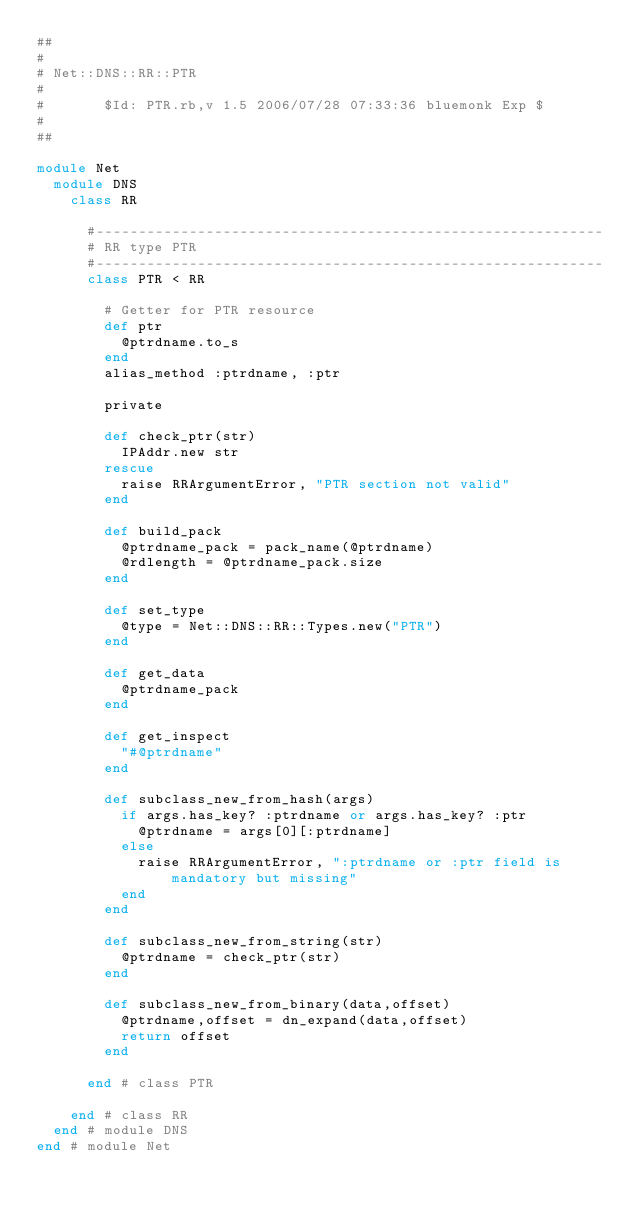<code> <loc_0><loc_0><loc_500><loc_500><_Ruby_>##
#
# Net::DNS::RR::PTR
#
#       $Id: PTR.rb,v 1.5 2006/07/28 07:33:36 bluemonk Exp $    
#
##

module Net
  module DNS
    class RR
      
      #------------------------------------------------------------
      # RR type PTR
      #------------------------------------------------------------
      class PTR < RR

        # Getter for PTR resource
        def ptr
          @ptrdname.to_s
        end
        alias_method :ptrdname, :ptr
        
        private
        
        def check_ptr(str)
          IPAddr.new str
        rescue
          raise RRArgumentError, "PTR section not valid"
        end
        
        def build_pack
          @ptrdname_pack = pack_name(@ptrdname)
          @rdlength = @ptrdname_pack.size
        end

        def set_type
          @type = Net::DNS::RR::Types.new("PTR")
        end

        def get_data
          @ptrdname_pack
        end

        def get_inspect
          "#@ptrdname"
        end

        def subclass_new_from_hash(args)
          if args.has_key? :ptrdname or args.has_key? :ptr
            @ptrdname = args[0][:ptrdname]
          else
            raise RRArgumentError, ":ptrdname or :ptr field is mandatory but missing"
          end
        end

        def subclass_new_from_string(str)
          @ptrdname = check_ptr(str)
        end

        def subclass_new_from_binary(data,offset)
          @ptrdname,offset = dn_expand(data,offset)
          return offset
        end

      end # class PTR
      
    end # class RR
  end # module DNS
end # module Net
</code> 